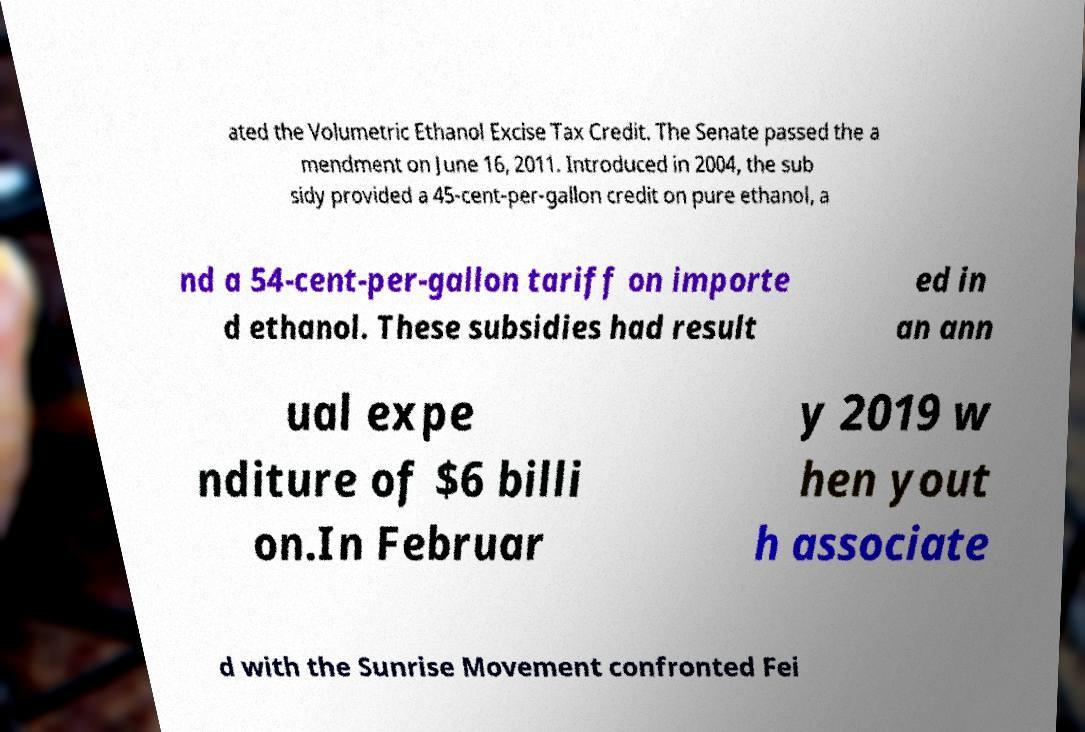What messages or text are displayed in this image? I need them in a readable, typed format. ated the Volumetric Ethanol Excise Tax Credit. The Senate passed the a mendment on June 16, 2011. Introduced in 2004, the sub sidy provided a 45-cent-per-gallon credit on pure ethanol, a nd a 54-cent-per-gallon tariff on importe d ethanol. These subsidies had result ed in an ann ual expe nditure of $6 billi on.In Februar y 2019 w hen yout h associate d with the Sunrise Movement confronted Fei 